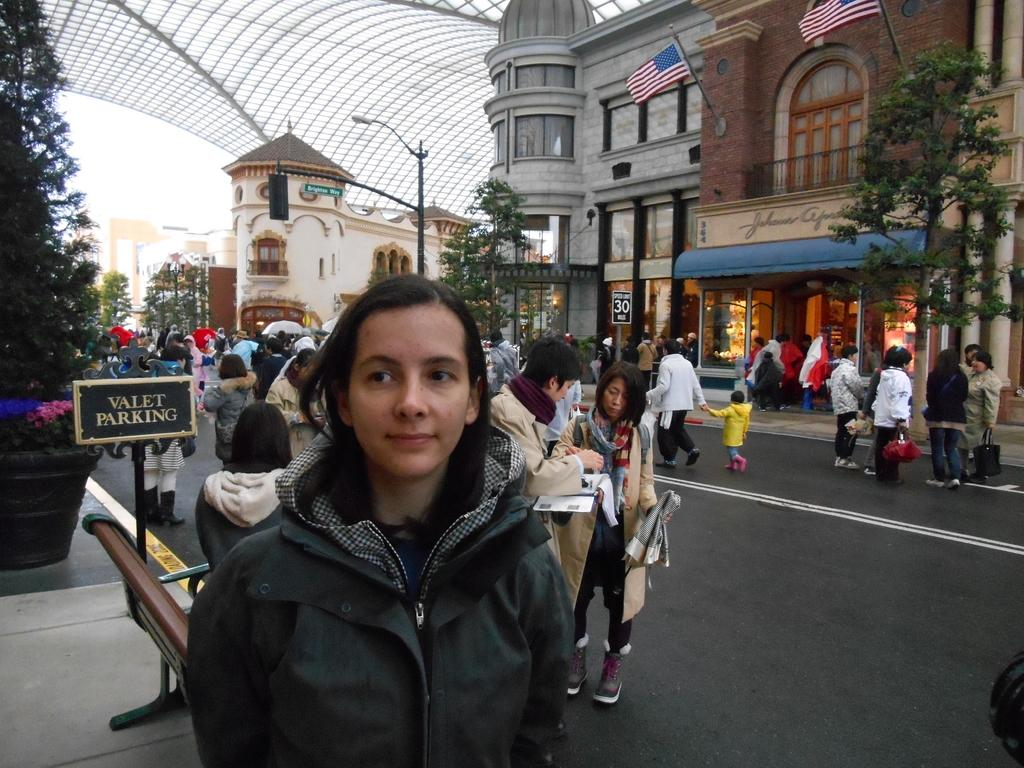What is the main subject of the image? There is a girl standing in the image. Are there any other people visible in the image? Yes, there are people standing on the road behind the girl. What can be seen in the distance in the image? There are buildings visible in the background of the image. What type of coal is being used to power the memory of the girl in the image? There is no coal or memory mentioned in the image; it simply shows a girl standing with people behind her and buildings in the background. 